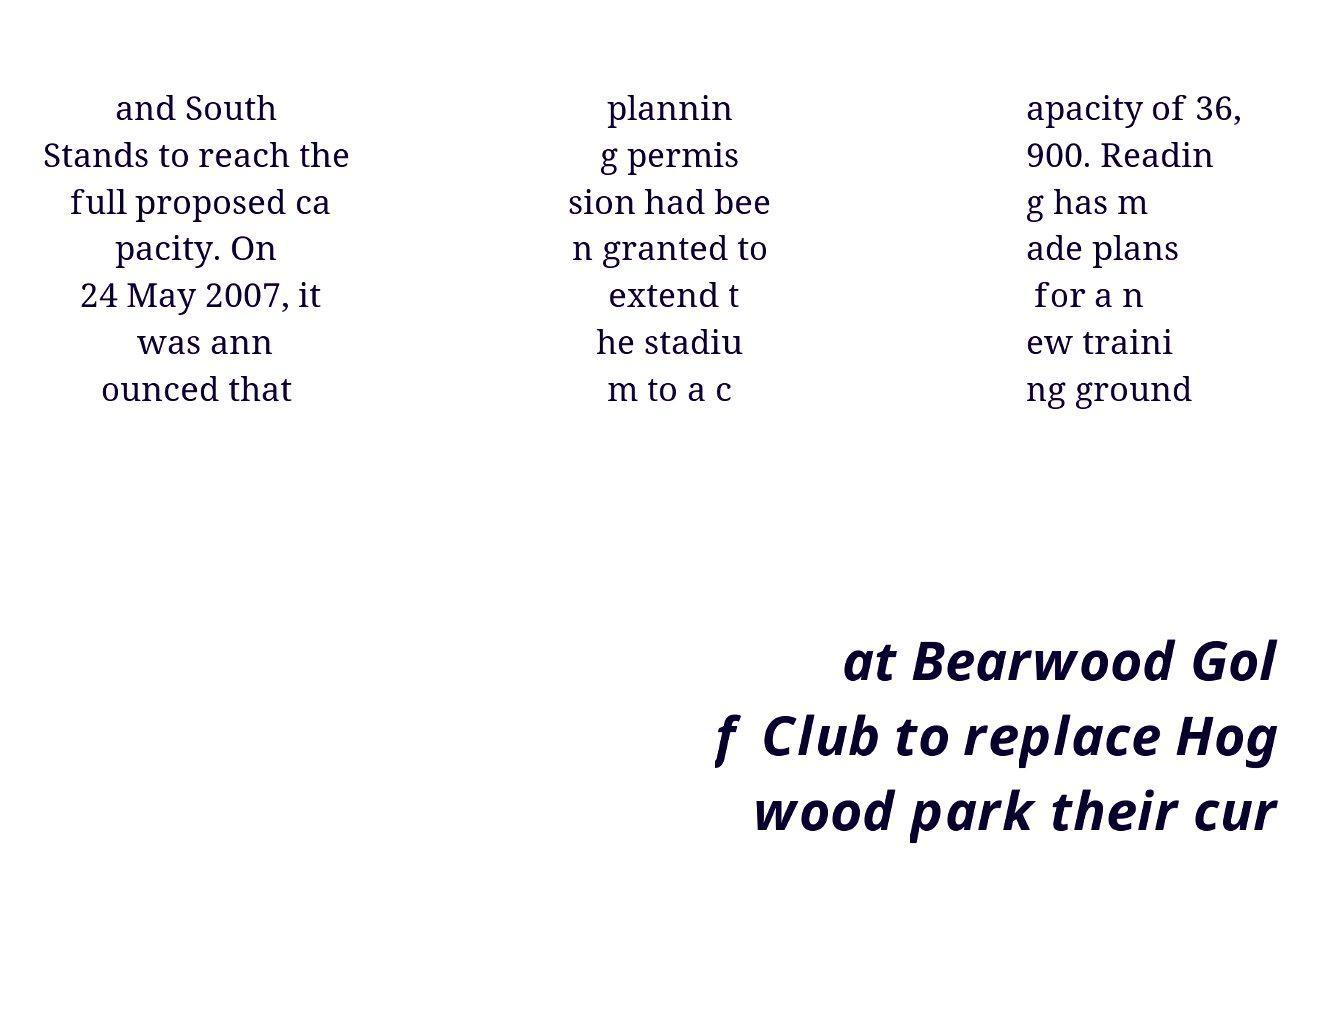Please identify and transcribe the text found in this image. and South Stands to reach the full proposed ca pacity. On 24 May 2007, it was ann ounced that plannin g permis sion had bee n granted to extend t he stadiu m to a c apacity of 36, 900. Readin g has m ade plans for a n ew traini ng ground at Bearwood Gol f Club to replace Hog wood park their cur 